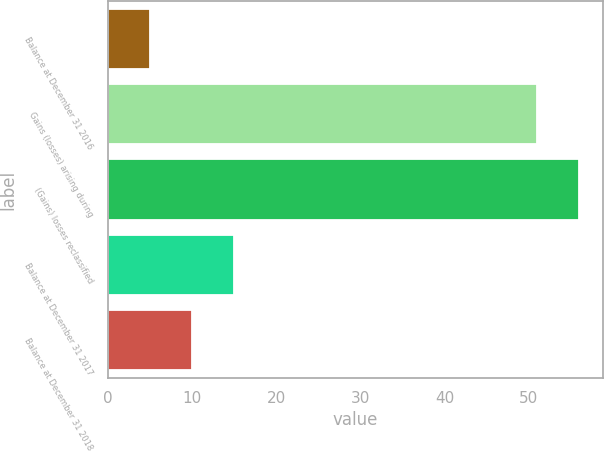<chart> <loc_0><loc_0><loc_500><loc_500><bar_chart><fcel>Balance at December 31 2016<fcel>Gains (losses) arising during<fcel>(Gains) losses reclassified<fcel>Balance at December 31 2017<fcel>Balance at December 31 2018<nl><fcel>5<fcel>51<fcel>56<fcel>15<fcel>10<nl></chart> 